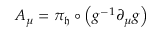<formula> <loc_0><loc_0><loc_500><loc_500>A _ { \mu } = \pi _ { \mathfrak { h } } \circ \left ( g ^ { - 1 } \partial _ { \mu } g \right )</formula> 